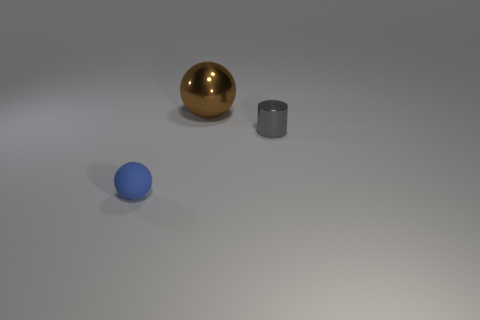What materials do the objects seem to be made from? The spherical object on the left seems to be made of a polished metal with a golden color, indicative of brass or gold, reflecting the environment with a high sheen. The smaller, cylindrical object also has a reflective surface, suggesting it could be made of steel or aluminum. The blue object appears to have a matte finish, which could suggest a plastic or painted wooden material. 